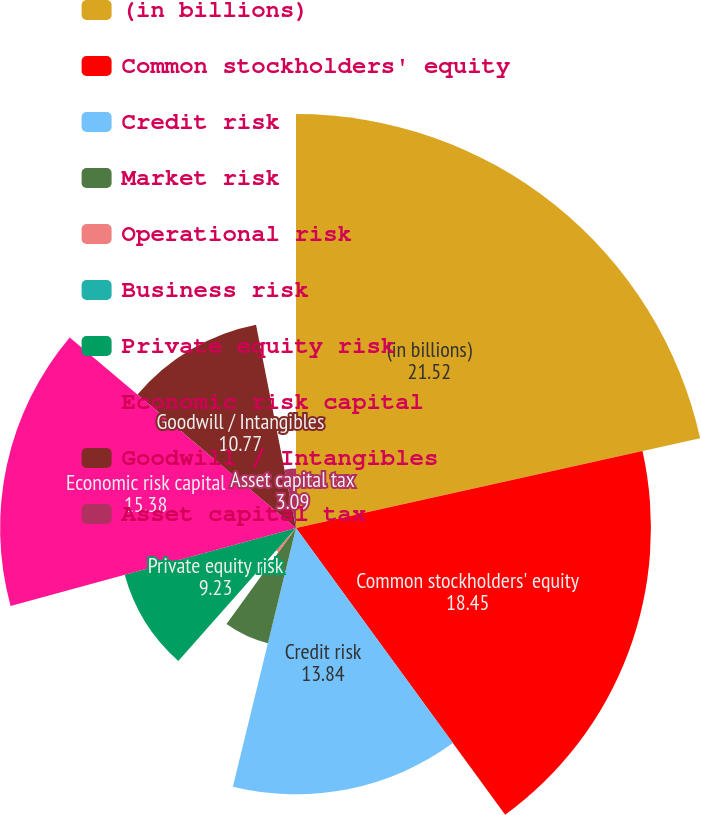Convert chart. <chart><loc_0><loc_0><loc_500><loc_500><pie_chart><fcel>(in billions)<fcel>Common stockholders' equity<fcel>Credit risk<fcel>Market risk<fcel>Operational risk<fcel>Business risk<fcel>Private equity risk<fcel>Economic risk capital<fcel>Goodwill / Intangibles<fcel>Asset capital tax<nl><fcel>21.52%<fcel>18.45%<fcel>13.84%<fcel>6.16%<fcel>1.55%<fcel>0.01%<fcel>9.23%<fcel>15.38%<fcel>10.77%<fcel>3.09%<nl></chart> 